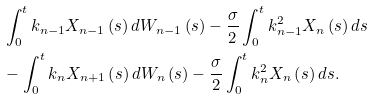Convert formula to latex. <formula><loc_0><loc_0><loc_500><loc_500>& \int _ { 0 } ^ { t } k _ { n - 1 } X _ { n - 1 } \left ( s \right ) d W _ { n - 1 } \left ( s \right ) - \frac { \sigma } { 2 } \int _ { 0 } ^ { t } k _ { n - 1 } ^ { 2 } X _ { n } \left ( s \right ) d s \\ & - \int _ { 0 } ^ { t } k _ { n } X _ { n + 1 } \left ( s \right ) d W _ { n } \left ( s \right ) - \frac { \sigma } { 2 } \int _ { 0 } ^ { t } k _ { n } ^ { 2 } X _ { n } \left ( s \right ) d s .</formula> 